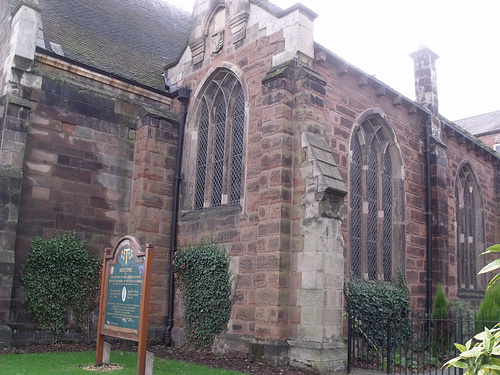<image>
Is the building behind the grass? Yes. From this viewpoint, the building is positioned behind the grass, with the grass partially or fully occluding the building. 